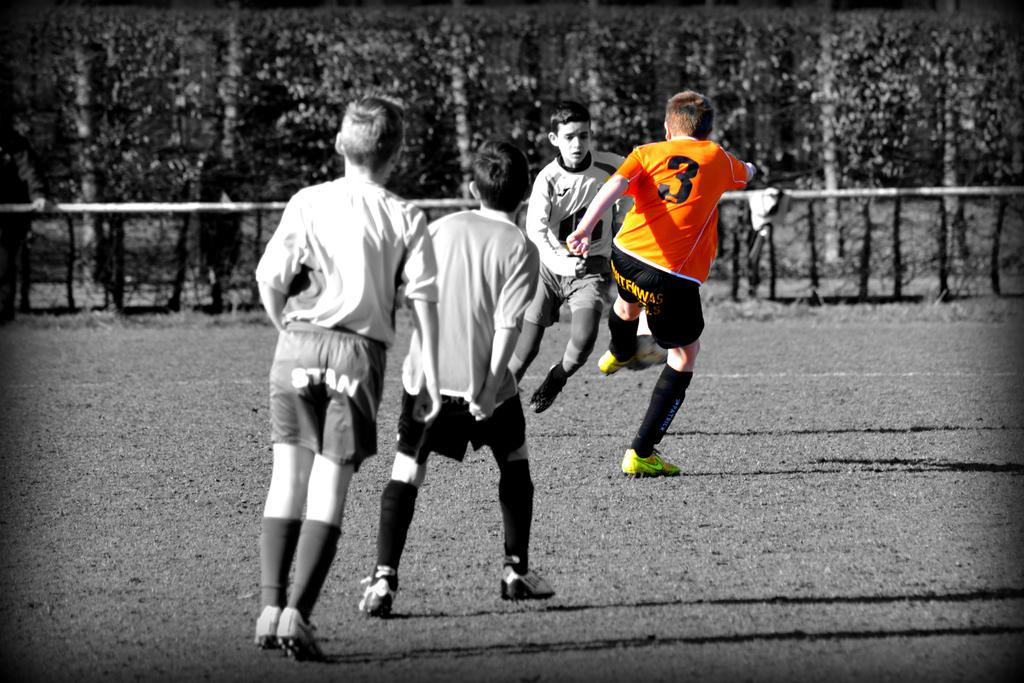How many children are present in the image? There are four children in the image. What activity are the children engaged in? The children are playing football. What type of surface are they playing on? There is a ground in the image where they are playing. What can be seen in the background of the image? There are trees near the ground, and there is a pole near the ground as well. What type of acoustics can be heard in the image? There is no information about any sounds or acoustics in the image, so it cannot be determined. --- Facts: 1. There is a car in the image. 2. The car is parked on the street. 3. There are buildings in the background. 4. The street has a sidewalk. 5. There are streetlights on the street. Absurd Topics: parrot, sandcastle, volcano Conversation: What type of vehicle is in the image? There is a car in the image. Where is the car located? The car is parked on the street. What can be seen in the background of the image? There are buildings in the background. What type of infrastructure is present on the street? The street has a sidewalk and streetlights. Reasoning: Let's think step by step in order to produce the conversation. We start by identifying the main subject of the image, which is the car. Then, we describe its location, which is parked on the street. Next, we mention the background elements, including the buildings. Finally, we describe the street infrastructure, which includes a sidewalk and streetlights. Absurd Question/Answer: Can you tell me where the parrot is building its sandcastle in the image? There is no parrot or sandcastle present in the image. --- Facts: 1. There is a person sitting on a bench. 2. The person is reading a book. 3. There is a tree near the bench. 4. The bench is in a park. 5. There are flowers near the bench. Absurd Topics: elephant, snow, telescope Conversation: What is the person in the image doing? The person is sitting on a bench and reading a book. What can be seen near the bench in the image? There is a tree and flowers near the bench. Where is the bench located? The bench is in a park. Reasoning: Let's think step by step in order to produce the conversation. We start by identifying the main subject of the image, which is the person sitting on the bench. Then, we describe their activity, which is reading a book. Next, we mention the nearby elements, including the tree and flowers. Finally, we describe the location of the bench, which is in a park. Absurd Question/Answer: 